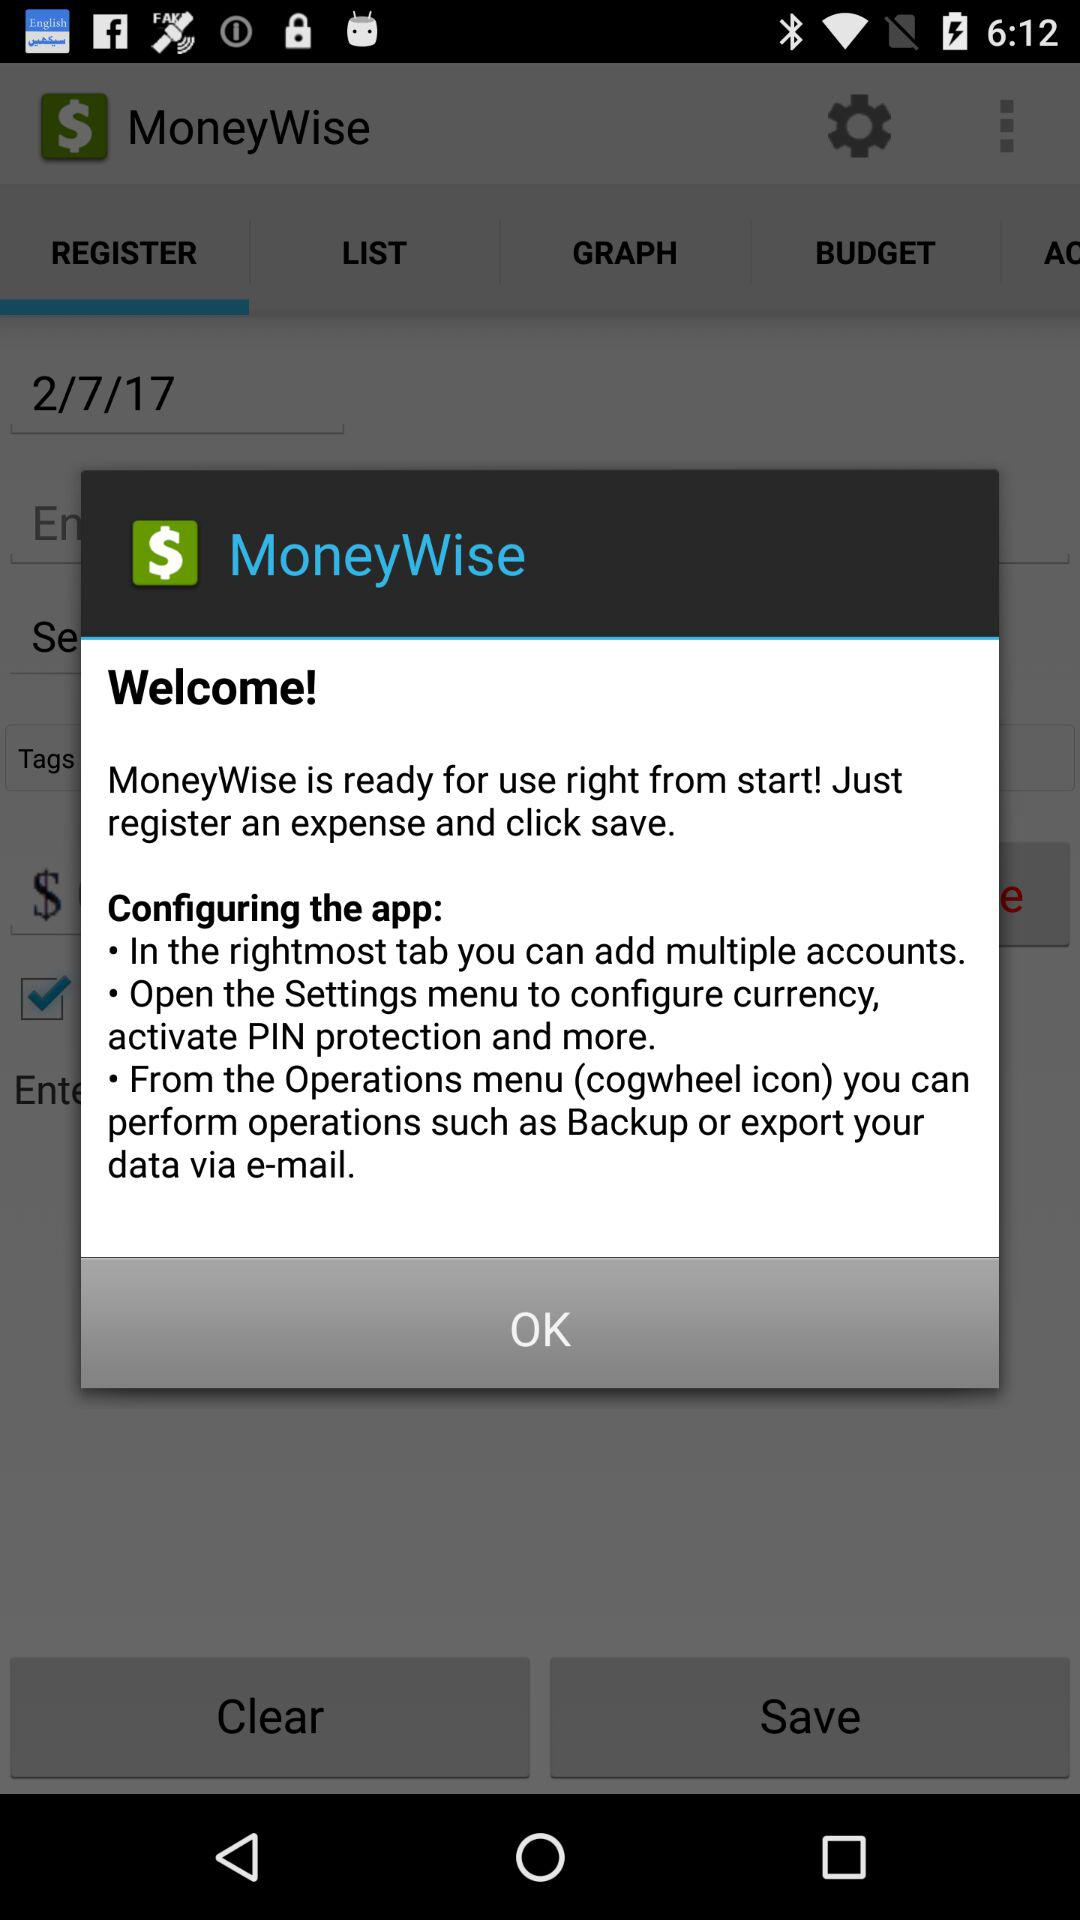How many instructions are there in the configuration section?
Answer the question using a single word or phrase. 3 